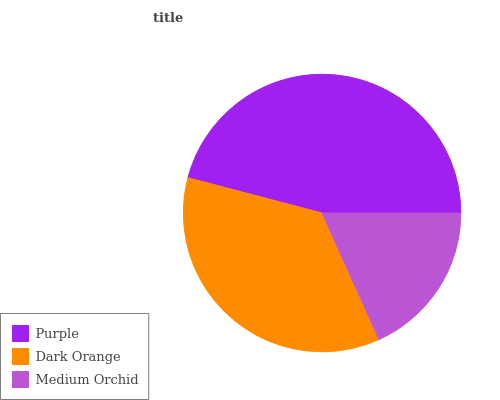Is Medium Orchid the minimum?
Answer yes or no. Yes. Is Purple the maximum?
Answer yes or no. Yes. Is Dark Orange the minimum?
Answer yes or no. No. Is Dark Orange the maximum?
Answer yes or no. No. Is Purple greater than Dark Orange?
Answer yes or no. Yes. Is Dark Orange less than Purple?
Answer yes or no. Yes. Is Dark Orange greater than Purple?
Answer yes or no. No. Is Purple less than Dark Orange?
Answer yes or no. No. Is Dark Orange the high median?
Answer yes or no. Yes. Is Dark Orange the low median?
Answer yes or no. Yes. Is Purple the high median?
Answer yes or no. No. Is Purple the low median?
Answer yes or no. No. 